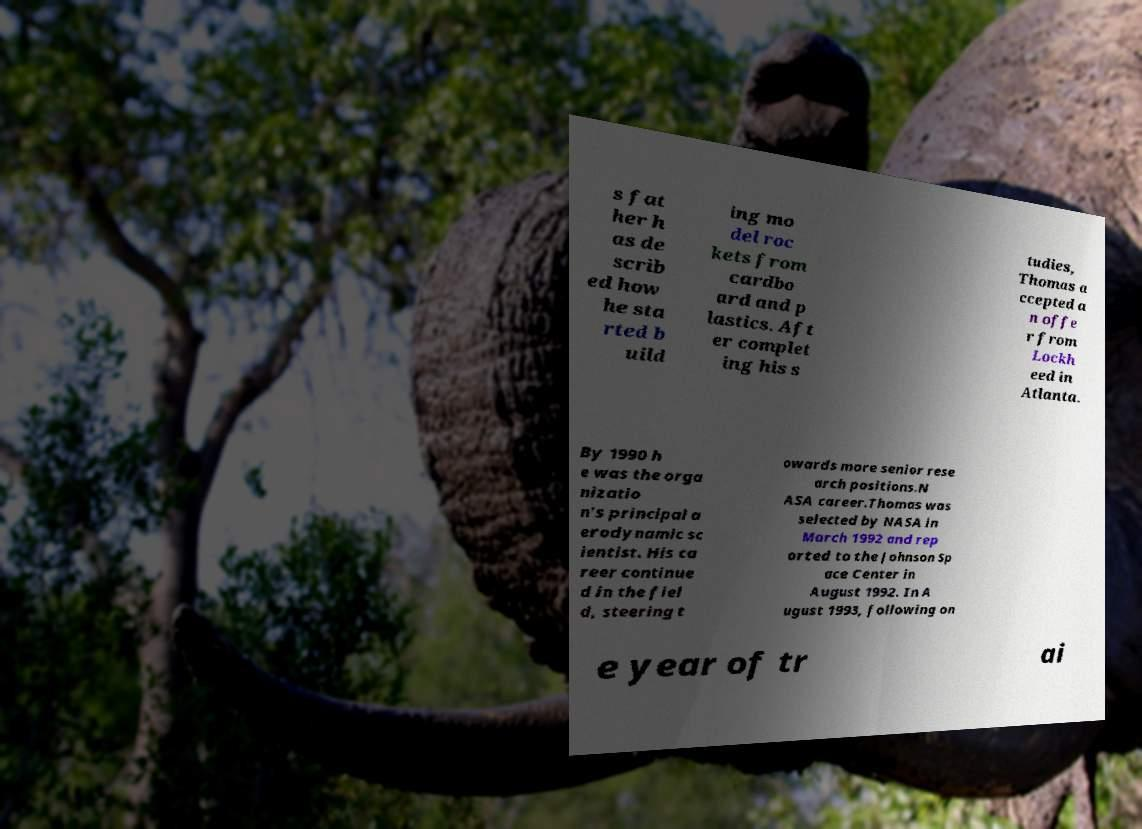Could you assist in decoding the text presented in this image and type it out clearly? s fat her h as de scrib ed how he sta rted b uild ing mo del roc kets from cardbo ard and p lastics. Aft er complet ing his s tudies, Thomas a ccepted a n offe r from Lockh eed in Atlanta. By 1990 h e was the orga nizatio n's principal a erodynamic sc ientist. His ca reer continue d in the fiel d, steering t owards more senior rese arch positions.N ASA career.Thomas was selected by NASA in March 1992 and rep orted to the Johnson Sp ace Center in August 1992. In A ugust 1993, following on e year of tr ai 